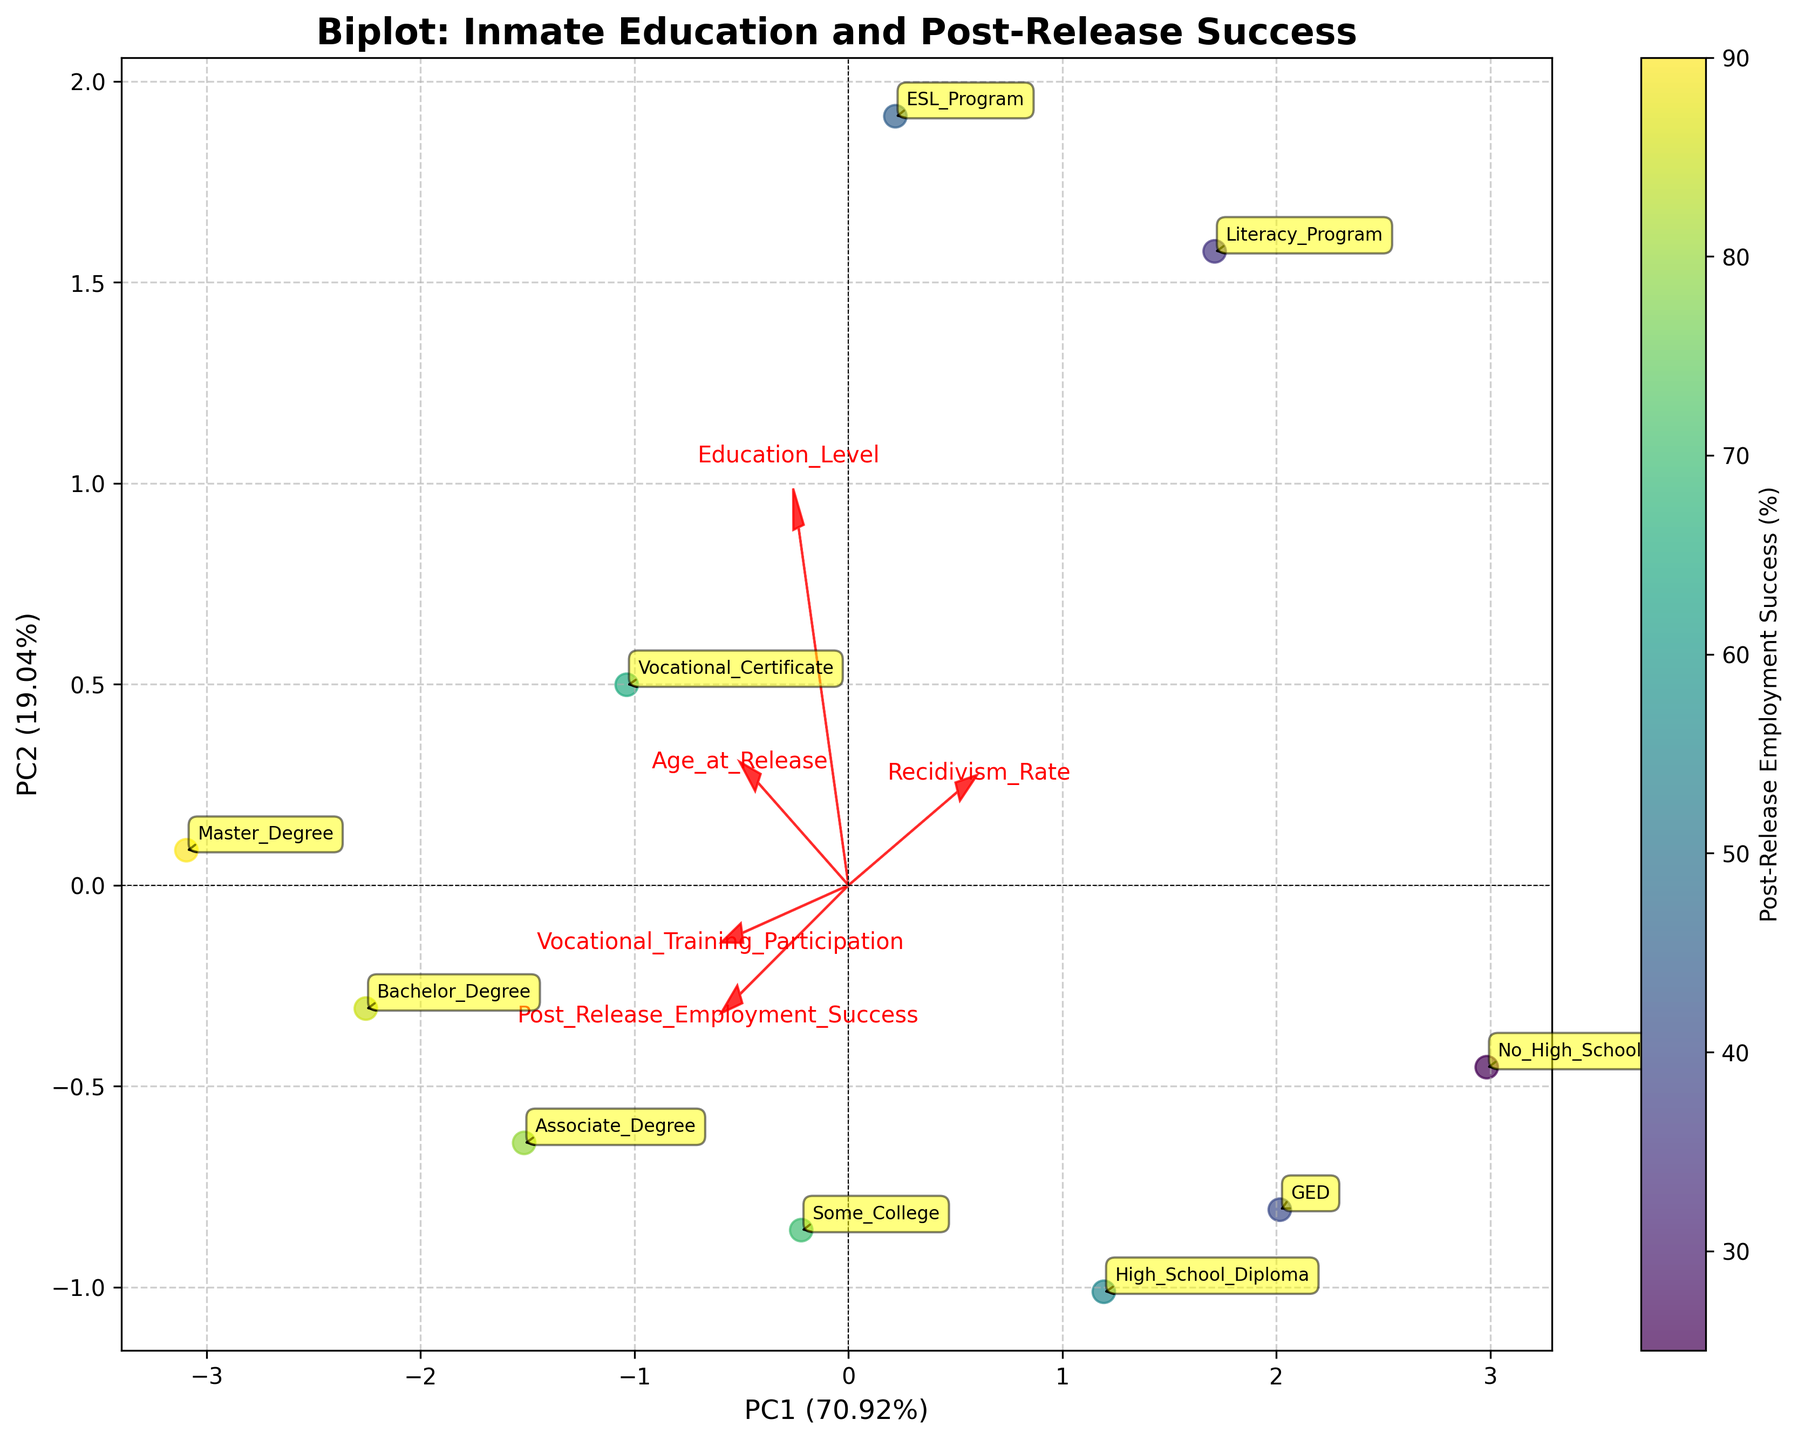What is the title of the plot? The title is typically located at the top center of the plot. In this figure, the bold text is "Biplot: Inmate Education and Post-Release Success".
Answer: Biplot: Inmate Education and Post-Release Success How many data points are shown in the biplot? By counting the number of unique annotations (representing different education levels) on the scatter plot, we can see there are 10 data points.
Answer: 10 Which education level has the highest post-release employment success rate? By analyzing the color gradient of the scatter plot, the data point with the highest value corresponds to a dark color. The annotation with the highest value is "Master Degree," situated around this color.
Answer: Master Degree What do the arrows represent in the biplot? The arrows correspond to different features in the dataset, indicating the direction and strength of their contribution to the principal components. They help visualize the association between the features and the principal components.
Answer: Feature vectors Which feature is most strongly correlated with PC1 (Principal Component 1)? By observing the arrow directions and lengths, the feature with the arrow most aligned and farthest along PC1 has the strongest correlation with PC1. In this case, "Post_Release_Employment_Success" appears to be most strongly correlated with PC1.
Answer: Post_Release_Employment_Success Which education level has the least post-release employment success rate? The education level corresponding to the lightest color on the scatter plot identifies the lowest post-release employment success. The annotation for this point is "No_High_School".
Answer: No_High_School What is the approximate angle between the arrows for "Recidivism_Rate" and "Post_Release_Employment_Success"? The approximate angle between these two arrows reflects their correlation. They are pointing in roughly opposite directions, indicating a negative correlation. The angle is close to 180 degrees.
Answer: 180 degrees How is vocational training participation related to post-release employment success? By observing the angles and lengths of the arrows, "Vocational_Training_Participation" and "Post_Release_Employment_Success" arrows point in nearly the same direction, indicating a positive correlation. They reinforce each other.
Answer: Positively correlated Which principal component (PC) explains the most variance in the data? The labels on the x-axis and y-axis indicate the explained variance for PC1 and PC2. By comparing these percentages, PC1 explains more variance than PC2.
Answer: PC1 